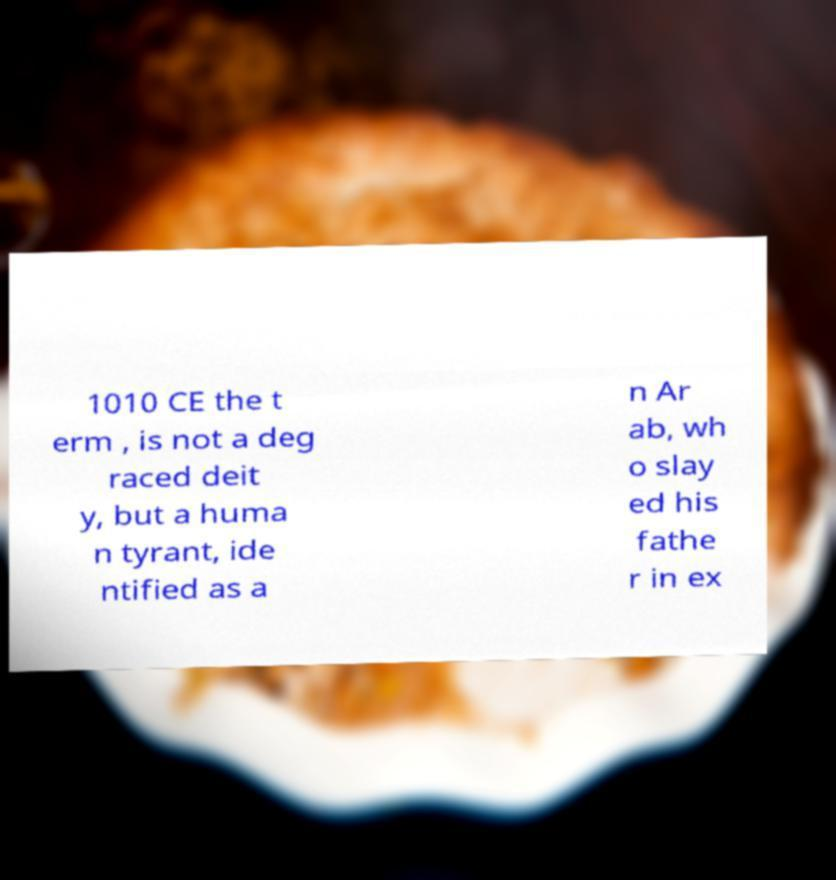There's text embedded in this image that I need extracted. Can you transcribe it verbatim? 1010 CE the t erm , is not a deg raced deit y, but a huma n tyrant, ide ntified as a n Ar ab, wh o slay ed his fathe r in ex 